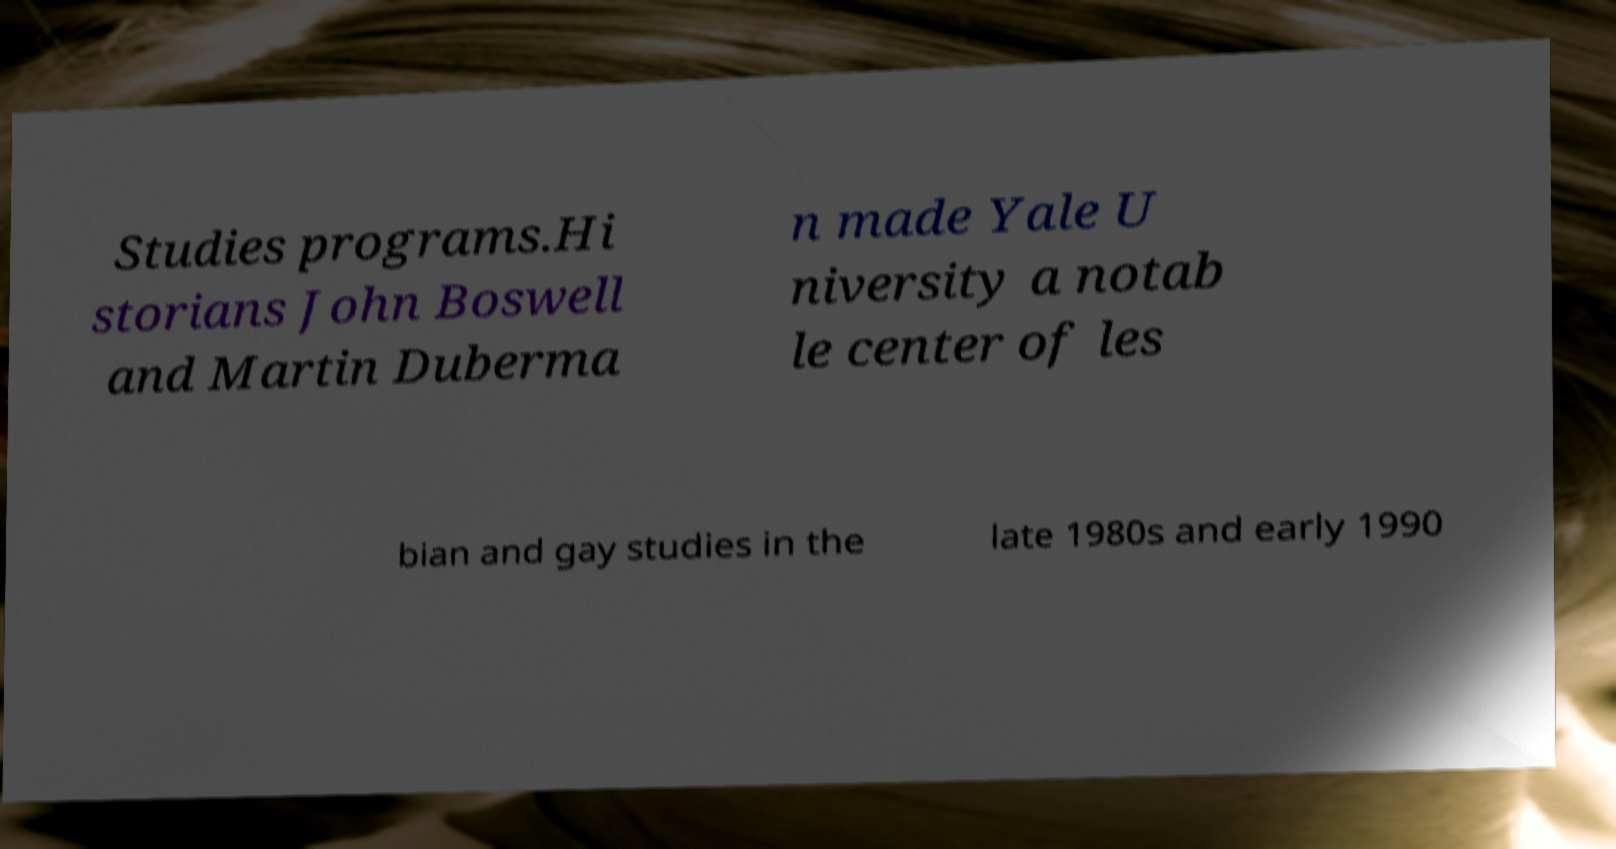For documentation purposes, I need the text within this image transcribed. Could you provide that? Studies programs.Hi storians John Boswell and Martin Duberma n made Yale U niversity a notab le center of les bian and gay studies in the late 1980s and early 1990 